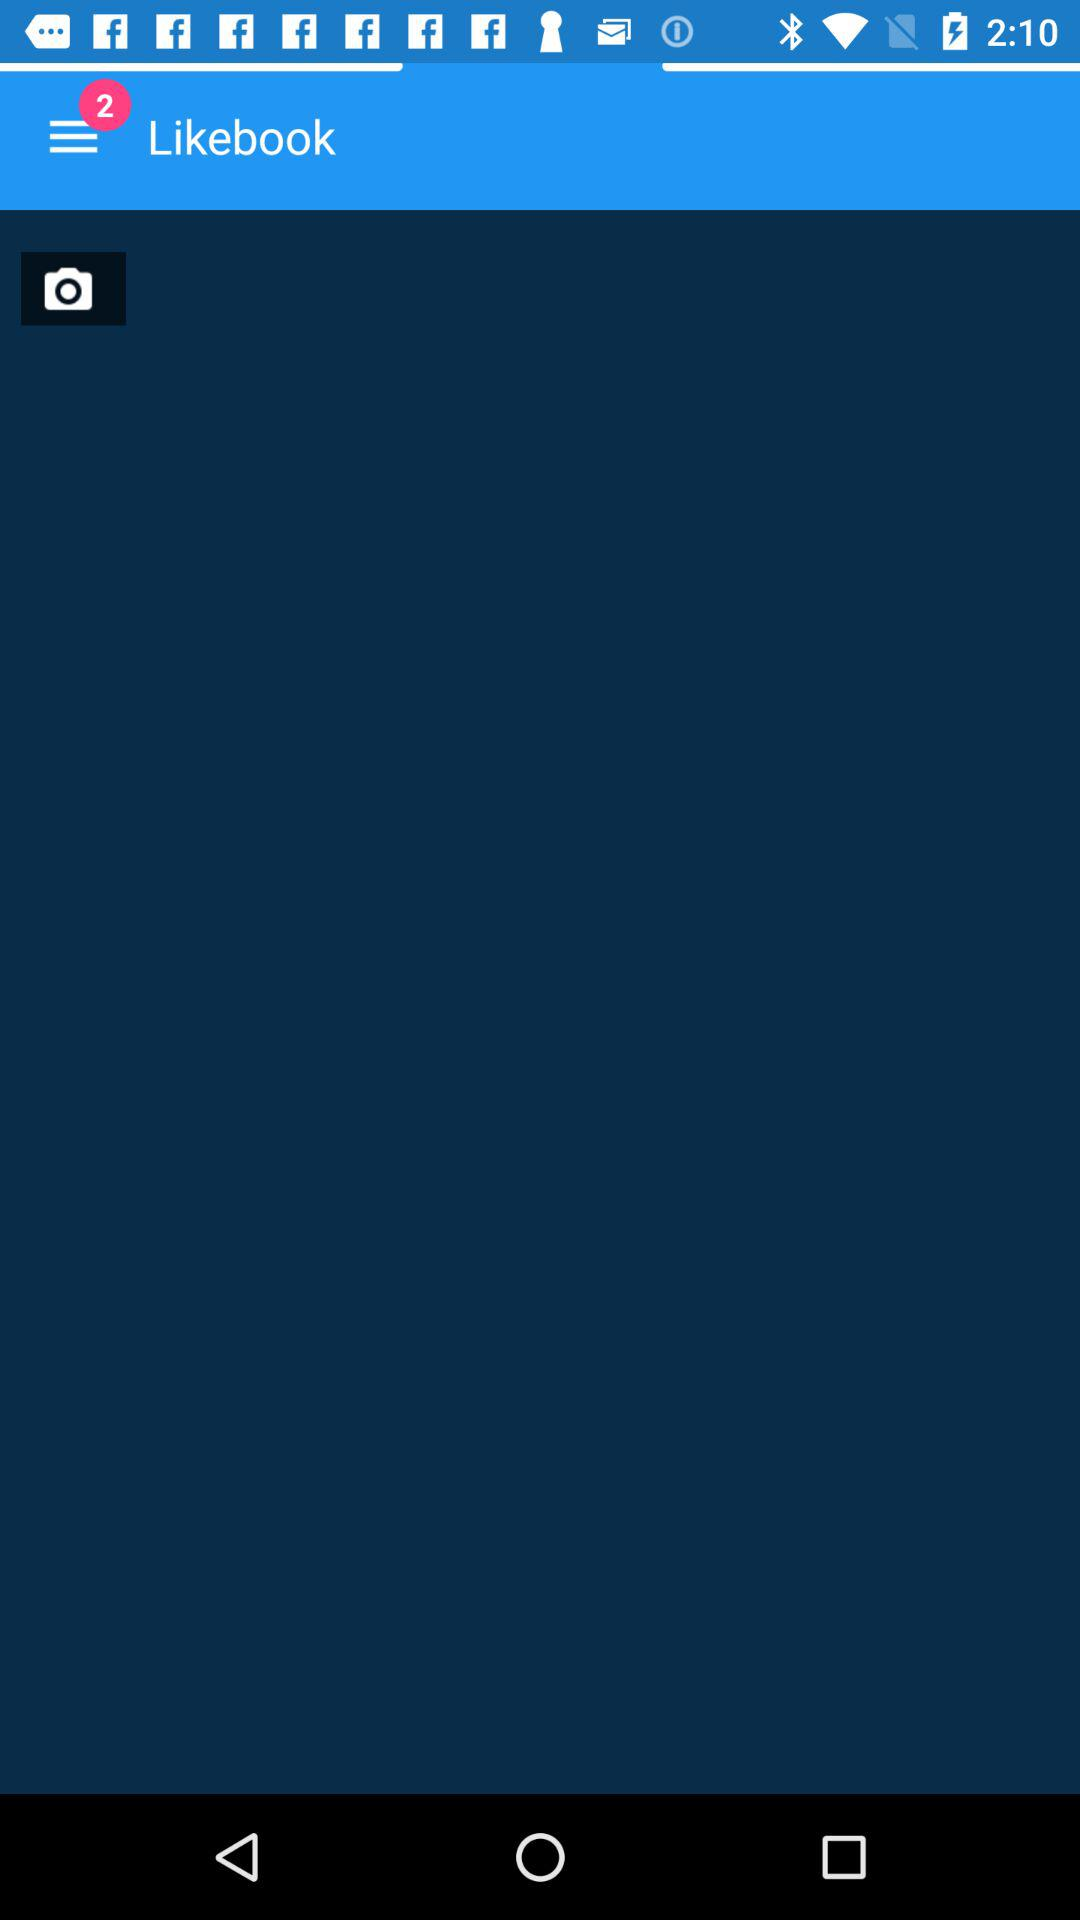How many notifications are shown? There are 2 shown notifications. 